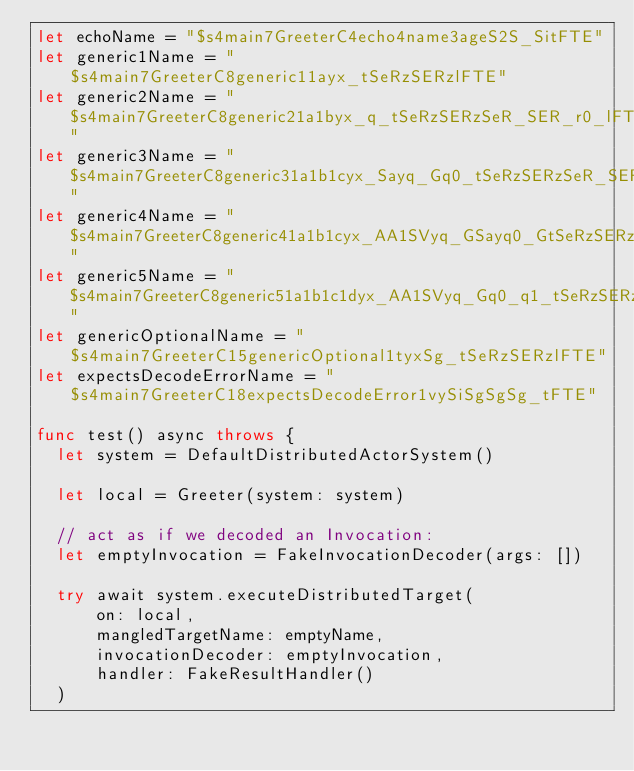Convert code to text. <code><loc_0><loc_0><loc_500><loc_500><_Swift_>let echoName = "$s4main7GreeterC4echo4name3ageS2S_SitFTE"
let generic1Name = "$s4main7GreeterC8generic11ayx_tSeRzSERzlFTE"
let generic2Name = "$s4main7GreeterC8generic21a1byx_q_tSeRzSERzSeR_SER_r0_lFTE"
let generic3Name = "$s4main7GreeterC8generic31a1b1cyx_Sayq_Gq0_tSeRzSERzSeR_SER_SeR0_SER0_r1_lFTE"
let generic4Name = "$s4main7GreeterC8generic41a1b1cyx_AA1SVyq_GSayq0_GtSeRzSERzSeR_SER_SeR0_SER0_r1_lFTE"
let generic5Name = "$s4main7GreeterC8generic51a1b1c1dyx_AA1SVyq_Gq0_q1_tSeRzSERzSeR_SER_SeR0_SER0_SeR1_SER1_r2_lFTE"
let genericOptionalName = "$s4main7GreeterC15genericOptional1tyxSg_tSeRzSERzlFTE"
let expectsDecodeErrorName = "$s4main7GreeterC18expectsDecodeError1vySiSgSgSg_tFTE"

func test() async throws {
  let system = DefaultDistributedActorSystem()

  let local = Greeter(system: system)

  // act as if we decoded an Invocation:
  let emptyInvocation = FakeInvocationDecoder(args: [])

  try await system.executeDistributedTarget(
      on: local,
      mangledTargetName: emptyName,
      invocationDecoder: emptyInvocation,
      handler: FakeResultHandler()
  )</code> 